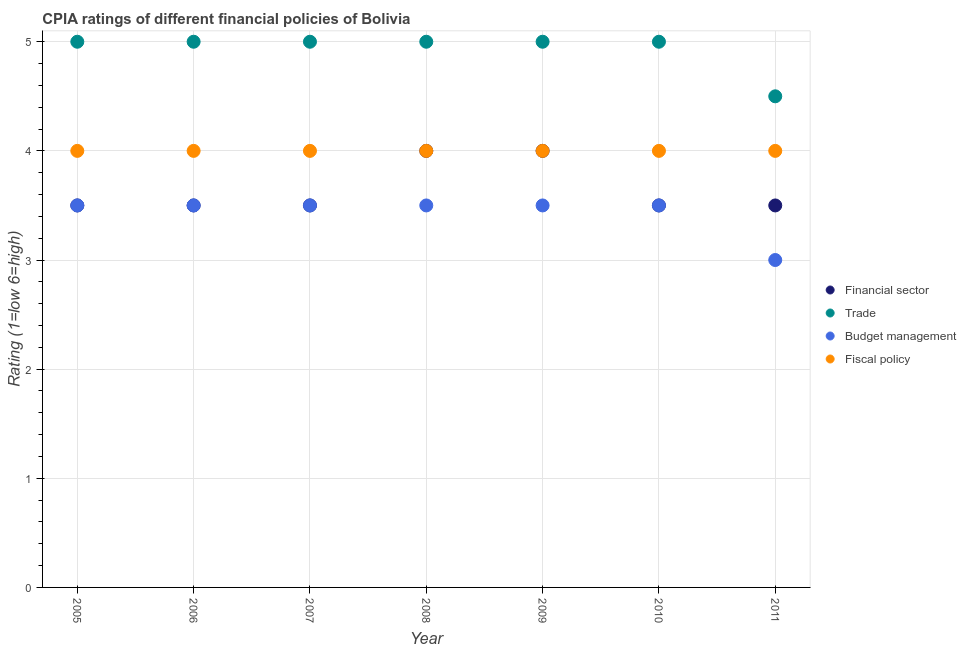Is the number of dotlines equal to the number of legend labels?
Offer a terse response. Yes. Across all years, what is the maximum cpia rating of financial sector?
Provide a short and direct response. 4. In which year was the cpia rating of financial sector maximum?
Provide a succinct answer. 2008. What is the difference between the cpia rating of trade in 2007 and that in 2008?
Keep it short and to the point. 0. What is the difference between the cpia rating of fiscal policy in 2005 and the cpia rating of budget management in 2009?
Ensure brevity in your answer.  0.5. In how many years, is the cpia rating of trade greater than 1.2?
Your response must be concise. 7. What is the ratio of the cpia rating of fiscal policy in 2006 to that in 2009?
Make the answer very short. 1. Is the cpia rating of financial sector in 2005 less than that in 2008?
Provide a succinct answer. Yes. In how many years, is the cpia rating of financial sector greater than the average cpia rating of financial sector taken over all years?
Provide a succinct answer. 2. Is the sum of the cpia rating of budget management in 2009 and 2010 greater than the maximum cpia rating of trade across all years?
Ensure brevity in your answer.  Yes. Is it the case that in every year, the sum of the cpia rating of fiscal policy and cpia rating of financial sector is greater than the sum of cpia rating of trade and cpia rating of budget management?
Ensure brevity in your answer.  Yes. Does the cpia rating of trade monotonically increase over the years?
Keep it short and to the point. No. Is the cpia rating of financial sector strictly greater than the cpia rating of trade over the years?
Ensure brevity in your answer.  No. Is the cpia rating of trade strictly less than the cpia rating of fiscal policy over the years?
Your answer should be compact. No. How many years are there in the graph?
Keep it short and to the point. 7. What is the difference between two consecutive major ticks on the Y-axis?
Your response must be concise. 1. Where does the legend appear in the graph?
Offer a very short reply. Center right. What is the title of the graph?
Provide a short and direct response. CPIA ratings of different financial policies of Bolivia. Does "Fish species" appear as one of the legend labels in the graph?
Provide a short and direct response. No. What is the label or title of the Y-axis?
Keep it short and to the point. Rating (1=low 6=high). What is the Rating (1=low 6=high) of Financial sector in 2005?
Provide a short and direct response. 3.5. What is the Rating (1=low 6=high) of Trade in 2005?
Your response must be concise. 5. What is the Rating (1=low 6=high) in Financial sector in 2006?
Keep it short and to the point. 3.5. What is the Rating (1=low 6=high) in Trade in 2006?
Offer a very short reply. 5. What is the Rating (1=low 6=high) in Budget management in 2006?
Make the answer very short. 3.5. What is the Rating (1=low 6=high) in Financial sector in 2008?
Your answer should be compact. 4. What is the Rating (1=low 6=high) in Financial sector in 2009?
Provide a short and direct response. 4. What is the Rating (1=low 6=high) in Fiscal policy in 2009?
Offer a very short reply. 4. What is the Rating (1=low 6=high) in Financial sector in 2010?
Provide a short and direct response. 3.5. What is the Rating (1=low 6=high) in Budget management in 2010?
Offer a terse response. 3.5. What is the Rating (1=low 6=high) of Financial sector in 2011?
Ensure brevity in your answer.  3.5. What is the Rating (1=low 6=high) of Trade in 2011?
Give a very brief answer. 4.5. What is the Rating (1=low 6=high) of Budget management in 2011?
Give a very brief answer. 3. Across all years, what is the maximum Rating (1=low 6=high) of Budget management?
Make the answer very short. 3.5. Across all years, what is the minimum Rating (1=low 6=high) of Budget management?
Your response must be concise. 3. Across all years, what is the minimum Rating (1=low 6=high) in Fiscal policy?
Offer a terse response. 4. What is the total Rating (1=low 6=high) of Financial sector in the graph?
Offer a terse response. 25.5. What is the total Rating (1=low 6=high) of Trade in the graph?
Your answer should be compact. 34.5. What is the difference between the Rating (1=low 6=high) in Financial sector in 2005 and that in 2006?
Make the answer very short. 0. What is the difference between the Rating (1=low 6=high) in Trade in 2005 and that in 2006?
Ensure brevity in your answer.  0. What is the difference between the Rating (1=low 6=high) of Fiscal policy in 2005 and that in 2006?
Provide a short and direct response. 0. What is the difference between the Rating (1=low 6=high) of Trade in 2005 and that in 2007?
Ensure brevity in your answer.  0. What is the difference between the Rating (1=low 6=high) in Budget management in 2005 and that in 2007?
Offer a terse response. 0. What is the difference between the Rating (1=low 6=high) in Budget management in 2005 and that in 2008?
Give a very brief answer. 0. What is the difference between the Rating (1=low 6=high) of Fiscal policy in 2005 and that in 2008?
Provide a succinct answer. 0. What is the difference between the Rating (1=low 6=high) in Trade in 2005 and that in 2010?
Keep it short and to the point. 0. What is the difference between the Rating (1=low 6=high) in Fiscal policy in 2005 and that in 2010?
Your answer should be very brief. 0. What is the difference between the Rating (1=low 6=high) in Financial sector in 2005 and that in 2011?
Make the answer very short. 0. What is the difference between the Rating (1=low 6=high) of Budget management in 2005 and that in 2011?
Provide a succinct answer. 0.5. What is the difference between the Rating (1=low 6=high) of Trade in 2006 and that in 2007?
Provide a short and direct response. 0. What is the difference between the Rating (1=low 6=high) of Fiscal policy in 2006 and that in 2007?
Keep it short and to the point. 0. What is the difference between the Rating (1=low 6=high) in Financial sector in 2006 and that in 2008?
Provide a succinct answer. -0.5. What is the difference between the Rating (1=low 6=high) of Budget management in 2006 and that in 2009?
Keep it short and to the point. 0. What is the difference between the Rating (1=low 6=high) in Fiscal policy in 2006 and that in 2009?
Offer a terse response. 0. What is the difference between the Rating (1=low 6=high) of Financial sector in 2006 and that in 2010?
Offer a very short reply. 0. What is the difference between the Rating (1=low 6=high) in Budget management in 2006 and that in 2010?
Your answer should be very brief. 0. What is the difference between the Rating (1=low 6=high) of Fiscal policy in 2006 and that in 2010?
Provide a succinct answer. 0. What is the difference between the Rating (1=low 6=high) of Financial sector in 2006 and that in 2011?
Make the answer very short. 0. What is the difference between the Rating (1=low 6=high) in Trade in 2006 and that in 2011?
Make the answer very short. 0.5. What is the difference between the Rating (1=low 6=high) of Budget management in 2007 and that in 2008?
Give a very brief answer. 0. What is the difference between the Rating (1=low 6=high) in Budget management in 2007 and that in 2009?
Ensure brevity in your answer.  0. What is the difference between the Rating (1=low 6=high) of Financial sector in 2007 and that in 2010?
Offer a terse response. 0. What is the difference between the Rating (1=low 6=high) of Budget management in 2007 and that in 2010?
Keep it short and to the point. 0. What is the difference between the Rating (1=low 6=high) of Budget management in 2007 and that in 2011?
Provide a short and direct response. 0.5. What is the difference between the Rating (1=low 6=high) of Financial sector in 2008 and that in 2009?
Your response must be concise. 0. What is the difference between the Rating (1=low 6=high) in Fiscal policy in 2008 and that in 2009?
Your answer should be very brief. 0. What is the difference between the Rating (1=low 6=high) in Financial sector in 2008 and that in 2010?
Your response must be concise. 0.5. What is the difference between the Rating (1=low 6=high) of Budget management in 2008 and that in 2011?
Make the answer very short. 0.5. What is the difference between the Rating (1=low 6=high) of Budget management in 2009 and that in 2010?
Give a very brief answer. 0. What is the difference between the Rating (1=low 6=high) in Budget management in 2009 and that in 2011?
Your answer should be compact. 0.5. What is the difference between the Rating (1=low 6=high) of Fiscal policy in 2009 and that in 2011?
Provide a short and direct response. 0. What is the difference between the Rating (1=low 6=high) of Financial sector in 2010 and that in 2011?
Keep it short and to the point. 0. What is the difference between the Rating (1=low 6=high) in Trade in 2005 and the Rating (1=low 6=high) in Budget management in 2006?
Offer a terse response. 1.5. What is the difference between the Rating (1=low 6=high) in Trade in 2005 and the Rating (1=low 6=high) in Fiscal policy in 2006?
Make the answer very short. 1. What is the difference between the Rating (1=low 6=high) of Financial sector in 2005 and the Rating (1=low 6=high) of Budget management in 2007?
Provide a short and direct response. 0. What is the difference between the Rating (1=low 6=high) of Financial sector in 2005 and the Rating (1=low 6=high) of Fiscal policy in 2007?
Your answer should be very brief. -0.5. What is the difference between the Rating (1=low 6=high) of Trade in 2005 and the Rating (1=low 6=high) of Budget management in 2007?
Make the answer very short. 1.5. What is the difference between the Rating (1=low 6=high) of Trade in 2005 and the Rating (1=low 6=high) of Fiscal policy in 2007?
Your answer should be very brief. 1. What is the difference between the Rating (1=low 6=high) in Financial sector in 2005 and the Rating (1=low 6=high) in Trade in 2008?
Offer a terse response. -1.5. What is the difference between the Rating (1=low 6=high) in Trade in 2005 and the Rating (1=low 6=high) in Budget management in 2008?
Your response must be concise. 1.5. What is the difference between the Rating (1=low 6=high) in Trade in 2005 and the Rating (1=low 6=high) in Fiscal policy in 2008?
Your response must be concise. 1. What is the difference between the Rating (1=low 6=high) of Financial sector in 2005 and the Rating (1=low 6=high) of Trade in 2009?
Provide a succinct answer. -1.5. What is the difference between the Rating (1=low 6=high) in Trade in 2005 and the Rating (1=low 6=high) in Fiscal policy in 2009?
Your answer should be compact. 1. What is the difference between the Rating (1=low 6=high) in Financial sector in 2005 and the Rating (1=low 6=high) in Fiscal policy in 2010?
Ensure brevity in your answer.  -0.5. What is the difference between the Rating (1=low 6=high) of Trade in 2005 and the Rating (1=low 6=high) of Fiscal policy in 2010?
Provide a succinct answer. 1. What is the difference between the Rating (1=low 6=high) of Budget management in 2005 and the Rating (1=low 6=high) of Fiscal policy in 2010?
Offer a very short reply. -0.5. What is the difference between the Rating (1=low 6=high) of Trade in 2005 and the Rating (1=low 6=high) of Budget management in 2011?
Your answer should be very brief. 2. What is the difference between the Rating (1=low 6=high) in Trade in 2005 and the Rating (1=low 6=high) in Fiscal policy in 2011?
Offer a terse response. 1. What is the difference between the Rating (1=low 6=high) of Budget management in 2005 and the Rating (1=low 6=high) of Fiscal policy in 2011?
Give a very brief answer. -0.5. What is the difference between the Rating (1=low 6=high) in Financial sector in 2006 and the Rating (1=low 6=high) in Trade in 2007?
Keep it short and to the point. -1.5. What is the difference between the Rating (1=low 6=high) of Financial sector in 2006 and the Rating (1=low 6=high) of Budget management in 2007?
Keep it short and to the point. 0. What is the difference between the Rating (1=low 6=high) of Financial sector in 2006 and the Rating (1=low 6=high) of Fiscal policy in 2007?
Make the answer very short. -0.5. What is the difference between the Rating (1=low 6=high) of Budget management in 2006 and the Rating (1=low 6=high) of Fiscal policy in 2007?
Make the answer very short. -0.5. What is the difference between the Rating (1=low 6=high) of Trade in 2006 and the Rating (1=low 6=high) of Budget management in 2008?
Offer a very short reply. 1.5. What is the difference between the Rating (1=low 6=high) in Budget management in 2006 and the Rating (1=low 6=high) in Fiscal policy in 2008?
Keep it short and to the point. -0.5. What is the difference between the Rating (1=low 6=high) of Financial sector in 2006 and the Rating (1=low 6=high) of Trade in 2009?
Your answer should be very brief. -1.5. What is the difference between the Rating (1=low 6=high) in Financial sector in 2006 and the Rating (1=low 6=high) in Budget management in 2009?
Keep it short and to the point. 0. What is the difference between the Rating (1=low 6=high) in Budget management in 2006 and the Rating (1=low 6=high) in Fiscal policy in 2009?
Make the answer very short. -0.5. What is the difference between the Rating (1=low 6=high) in Financial sector in 2006 and the Rating (1=low 6=high) in Trade in 2010?
Keep it short and to the point. -1.5. What is the difference between the Rating (1=low 6=high) of Trade in 2006 and the Rating (1=low 6=high) of Budget management in 2010?
Give a very brief answer. 1.5. What is the difference between the Rating (1=low 6=high) in Trade in 2006 and the Rating (1=low 6=high) in Fiscal policy in 2010?
Give a very brief answer. 1. What is the difference between the Rating (1=low 6=high) of Budget management in 2006 and the Rating (1=low 6=high) of Fiscal policy in 2010?
Make the answer very short. -0.5. What is the difference between the Rating (1=low 6=high) in Financial sector in 2006 and the Rating (1=low 6=high) in Trade in 2011?
Keep it short and to the point. -1. What is the difference between the Rating (1=low 6=high) of Financial sector in 2006 and the Rating (1=low 6=high) of Fiscal policy in 2011?
Give a very brief answer. -0.5. What is the difference between the Rating (1=low 6=high) of Trade in 2006 and the Rating (1=low 6=high) of Budget management in 2011?
Make the answer very short. 2. What is the difference between the Rating (1=low 6=high) in Budget management in 2006 and the Rating (1=low 6=high) in Fiscal policy in 2011?
Offer a terse response. -0.5. What is the difference between the Rating (1=low 6=high) of Financial sector in 2007 and the Rating (1=low 6=high) of Trade in 2008?
Your response must be concise. -1.5. What is the difference between the Rating (1=low 6=high) in Financial sector in 2007 and the Rating (1=low 6=high) in Fiscal policy in 2008?
Offer a very short reply. -0.5. What is the difference between the Rating (1=low 6=high) in Trade in 2007 and the Rating (1=low 6=high) in Budget management in 2008?
Provide a succinct answer. 1.5. What is the difference between the Rating (1=low 6=high) of Trade in 2007 and the Rating (1=low 6=high) of Fiscal policy in 2008?
Your answer should be very brief. 1. What is the difference between the Rating (1=low 6=high) in Financial sector in 2007 and the Rating (1=low 6=high) in Trade in 2009?
Provide a succinct answer. -1.5. What is the difference between the Rating (1=low 6=high) of Financial sector in 2007 and the Rating (1=low 6=high) of Budget management in 2009?
Offer a very short reply. 0. What is the difference between the Rating (1=low 6=high) of Financial sector in 2007 and the Rating (1=low 6=high) of Fiscal policy in 2009?
Provide a short and direct response. -0.5. What is the difference between the Rating (1=low 6=high) in Budget management in 2007 and the Rating (1=low 6=high) in Fiscal policy in 2009?
Your response must be concise. -0.5. What is the difference between the Rating (1=low 6=high) of Financial sector in 2007 and the Rating (1=low 6=high) of Trade in 2010?
Provide a short and direct response. -1.5. What is the difference between the Rating (1=low 6=high) of Financial sector in 2007 and the Rating (1=low 6=high) of Budget management in 2010?
Make the answer very short. 0. What is the difference between the Rating (1=low 6=high) of Trade in 2007 and the Rating (1=low 6=high) of Budget management in 2010?
Provide a short and direct response. 1.5. What is the difference between the Rating (1=low 6=high) in Trade in 2007 and the Rating (1=low 6=high) in Fiscal policy in 2010?
Your response must be concise. 1. What is the difference between the Rating (1=low 6=high) of Budget management in 2007 and the Rating (1=low 6=high) of Fiscal policy in 2010?
Provide a short and direct response. -0.5. What is the difference between the Rating (1=low 6=high) of Trade in 2007 and the Rating (1=low 6=high) of Budget management in 2011?
Ensure brevity in your answer.  2. What is the difference between the Rating (1=low 6=high) of Trade in 2007 and the Rating (1=low 6=high) of Fiscal policy in 2011?
Ensure brevity in your answer.  1. What is the difference between the Rating (1=low 6=high) in Budget management in 2007 and the Rating (1=low 6=high) in Fiscal policy in 2011?
Make the answer very short. -0.5. What is the difference between the Rating (1=low 6=high) in Financial sector in 2008 and the Rating (1=low 6=high) in Budget management in 2009?
Offer a very short reply. 0.5. What is the difference between the Rating (1=low 6=high) in Financial sector in 2008 and the Rating (1=low 6=high) in Fiscal policy in 2009?
Make the answer very short. 0. What is the difference between the Rating (1=low 6=high) of Budget management in 2008 and the Rating (1=low 6=high) of Fiscal policy in 2009?
Offer a very short reply. -0.5. What is the difference between the Rating (1=low 6=high) in Financial sector in 2008 and the Rating (1=low 6=high) in Budget management in 2010?
Ensure brevity in your answer.  0.5. What is the difference between the Rating (1=low 6=high) in Financial sector in 2008 and the Rating (1=low 6=high) in Fiscal policy in 2010?
Offer a terse response. 0. What is the difference between the Rating (1=low 6=high) of Trade in 2008 and the Rating (1=low 6=high) of Fiscal policy in 2010?
Make the answer very short. 1. What is the difference between the Rating (1=low 6=high) in Budget management in 2008 and the Rating (1=low 6=high) in Fiscal policy in 2010?
Ensure brevity in your answer.  -0.5. What is the difference between the Rating (1=low 6=high) of Financial sector in 2008 and the Rating (1=low 6=high) of Fiscal policy in 2011?
Your answer should be compact. 0. What is the difference between the Rating (1=low 6=high) of Trade in 2008 and the Rating (1=low 6=high) of Fiscal policy in 2011?
Offer a very short reply. 1. What is the difference between the Rating (1=low 6=high) of Financial sector in 2009 and the Rating (1=low 6=high) of Budget management in 2010?
Offer a terse response. 0.5. What is the difference between the Rating (1=low 6=high) in Financial sector in 2009 and the Rating (1=low 6=high) in Fiscal policy in 2010?
Provide a succinct answer. 0. What is the difference between the Rating (1=low 6=high) in Trade in 2009 and the Rating (1=low 6=high) in Budget management in 2010?
Offer a very short reply. 1.5. What is the difference between the Rating (1=low 6=high) in Financial sector in 2009 and the Rating (1=low 6=high) in Budget management in 2011?
Give a very brief answer. 1. What is the difference between the Rating (1=low 6=high) of Trade in 2009 and the Rating (1=low 6=high) of Budget management in 2011?
Give a very brief answer. 2. What is the difference between the Rating (1=low 6=high) in Trade in 2009 and the Rating (1=low 6=high) in Fiscal policy in 2011?
Your response must be concise. 1. What is the difference between the Rating (1=low 6=high) in Budget management in 2009 and the Rating (1=low 6=high) in Fiscal policy in 2011?
Ensure brevity in your answer.  -0.5. What is the difference between the Rating (1=low 6=high) in Financial sector in 2010 and the Rating (1=low 6=high) in Budget management in 2011?
Your answer should be very brief. 0.5. What is the average Rating (1=low 6=high) in Financial sector per year?
Give a very brief answer. 3.64. What is the average Rating (1=low 6=high) in Trade per year?
Make the answer very short. 4.93. What is the average Rating (1=low 6=high) in Budget management per year?
Keep it short and to the point. 3.43. What is the average Rating (1=low 6=high) of Fiscal policy per year?
Offer a terse response. 4. In the year 2005, what is the difference between the Rating (1=low 6=high) in Financial sector and Rating (1=low 6=high) in Trade?
Offer a very short reply. -1.5. In the year 2005, what is the difference between the Rating (1=low 6=high) in Financial sector and Rating (1=low 6=high) in Budget management?
Provide a short and direct response. 0. In the year 2005, what is the difference between the Rating (1=low 6=high) in Financial sector and Rating (1=low 6=high) in Fiscal policy?
Provide a succinct answer. -0.5. In the year 2005, what is the difference between the Rating (1=low 6=high) of Budget management and Rating (1=low 6=high) of Fiscal policy?
Your answer should be very brief. -0.5. In the year 2006, what is the difference between the Rating (1=low 6=high) of Financial sector and Rating (1=low 6=high) of Trade?
Provide a succinct answer. -1.5. In the year 2006, what is the difference between the Rating (1=low 6=high) in Trade and Rating (1=low 6=high) in Budget management?
Provide a succinct answer. 1.5. In the year 2006, what is the difference between the Rating (1=low 6=high) in Trade and Rating (1=low 6=high) in Fiscal policy?
Make the answer very short. 1. In the year 2007, what is the difference between the Rating (1=low 6=high) in Trade and Rating (1=low 6=high) in Budget management?
Your answer should be very brief. 1.5. In the year 2007, what is the difference between the Rating (1=low 6=high) in Trade and Rating (1=low 6=high) in Fiscal policy?
Offer a very short reply. 1. In the year 2008, what is the difference between the Rating (1=low 6=high) of Financial sector and Rating (1=low 6=high) of Budget management?
Ensure brevity in your answer.  0.5. In the year 2008, what is the difference between the Rating (1=low 6=high) of Trade and Rating (1=low 6=high) of Fiscal policy?
Ensure brevity in your answer.  1. In the year 2009, what is the difference between the Rating (1=low 6=high) of Trade and Rating (1=low 6=high) of Fiscal policy?
Your answer should be very brief. 1. In the year 2010, what is the difference between the Rating (1=low 6=high) in Financial sector and Rating (1=low 6=high) in Budget management?
Provide a short and direct response. 0. In the year 2010, what is the difference between the Rating (1=low 6=high) in Financial sector and Rating (1=low 6=high) in Fiscal policy?
Ensure brevity in your answer.  -0.5. In the year 2010, what is the difference between the Rating (1=low 6=high) in Budget management and Rating (1=low 6=high) in Fiscal policy?
Provide a succinct answer. -0.5. In the year 2011, what is the difference between the Rating (1=low 6=high) in Financial sector and Rating (1=low 6=high) in Budget management?
Your answer should be compact. 0.5. In the year 2011, what is the difference between the Rating (1=low 6=high) of Financial sector and Rating (1=low 6=high) of Fiscal policy?
Ensure brevity in your answer.  -0.5. In the year 2011, what is the difference between the Rating (1=low 6=high) in Trade and Rating (1=low 6=high) in Fiscal policy?
Ensure brevity in your answer.  0.5. In the year 2011, what is the difference between the Rating (1=low 6=high) in Budget management and Rating (1=low 6=high) in Fiscal policy?
Make the answer very short. -1. What is the ratio of the Rating (1=low 6=high) in Financial sector in 2005 to that in 2006?
Offer a terse response. 1. What is the ratio of the Rating (1=low 6=high) in Trade in 2005 to that in 2006?
Make the answer very short. 1. What is the ratio of the Rating (1=low 6=high) of Fiscal policy in 2005 to that in 2006?
Provide a succinct answer. 1. What is the ratio of the Rating (1=low 6=high) in Financial sector in 2005 to that in 2007?
Offer a very short reply. 1. What is the ratio of the Rating (1=low 6=high) of Trade in 2005 to that in 2007?
Make the answer very short. 1. What is the ratio of the Rating (1=low 6=high) in Fiscal policy in 2005 to that in 2007?
Your answer should be compact. 1. What is the ratio of the Rating (1=low 6=high) in Financial sector in 2005 to that in 2008?
Provide a short and direct response. 0.88. What is the ratio of the Rating (1=low 6=high) of Budget management in 2005 to that in 2009?
Provide a short and direct response. 1. What is the ratio of the Rating (1=low 6=high) of Fiscal policy in 2005 to that in 2009?
Offer a very short reply. 1. What is the ratio of the Rating (1=low 6=high) of Financial sector in 2005 to that in 2010?
Provide a succinct answer. 1. What is the ratio of the Rating (1=low 6=high) of Trade in 2005 to that in 2010?
Make the answer very short. 1. What is the ratio of the Rating (1=low 6=high) of Budget management in 2005 to that in 2010?
Provide a short and direct response. 1. What is the ratio of the Rating (1=low 6=high) in Fiscal policy in 2005 to that in 2010?
Your response must be concise. 1. What is the ratio of the Rating (1=low 6=high) in Financial sector in 2006 to that in 2007?
Your response must be concise. 1. What is the ratio of the Rating (1=low 6=high) in Trade in 2006 to that in 2007?
Offer a terse response. 1. What is the ratio of the Rating (1=low 6=high) of Budget management in 2006 to that in 2007?
Your answer should be very brief. 1. What is the ratio of the Rating (1=low 6=high) in Financial sector in 2006 to that in 2008?
Offer a very short reply. 0.88. What is the ratio of the Rating (1=low 6=high) in Financial sector in 2006 to that in 2009?
Offer a terse response. 0.88. What is the ratio of the Rating (1=low 6=high) in Trade in 2006 to that in 2009?
Your answer should be very brief. 1. What is the ratio of the Rating (1=low 6=high) of Budget management in 2006 to that in 2009?
Your answer should be very brief. 1. What is the ratio of the Rating (1=low 6=high) of Trade in 2006 to that in 2010?
Your answer should be very brief. 1. What is the ratio of the Rating (1=low 6=high) of Budget management in 2006 to that in 2010?
Make the answer very short. 1. What is the ratio of the Rating (1=low 6=high) of Financial sector in 2006 to that in 2011?
Make the answer very short. 1. What is the ratio of the Rating (1=low 6=high) in Fiscal policy in 2006 to that in 2011?
Your response must be concise. 1. What is the ratio of the Rating (1=low 6=high) in Financial sector in 2007 to that in 2008?
Keep it short and to the point. 0.88. What is the ratio of the Rating (1=low 6=high) of Fiscal policy in 2007 to that in 2008?
Offer a terse response. 1. What is the ratio of the Rating (1=low 6=high) in Financial sector in 2007 to that in 2009?
Ensure brevity in your answer.  0.88. What is the ratio of the Rating (1=low 6=high) in Financial sector in 2007 to that in 2010?
Your answer should be very brief. 1. What is the ratio of the Rating (1=low 6=high) of Trade in 2007 to that in 2010?
Offer a terse response. 1. What is the ratio of the Rating (1=low 6=high) in Budget management in 2007 to that in 2010?
Keep it short and to the point. 1. What is the ratio of the Rating (1=low 6=high) of Fiscal policy in 2007 to that in 2010?
Provide a short and direct response. 1. What is the ratio of the Rating (1=low 6=high) of Financial sector in 2007 to that in 2011?
Provide a succinct answer. 1. What is the ratio of the Rating (1=low 6=high) of Budget management in 2007 to that in 2011?
Offer a very short reply. 1.17. What is the ratio of the Rating (1=low 6=high) of Fiscal policy in 2007 to that in 2011?
Provide a succinct answer. 1. What is the ratio of the Rating (1=low 6=high) of Financial sector in 2008 to that in 2009?
Your answer should be very brief. 1. What is the ratio of the Rating (1=low 6=high) of Trade in 2008 to that in 2010?
Provide a succinct answer. 1. What is the ratio of the Rating (1=low 6=high) of Budget management in 2008 to that in 2010?
Make the answer very short. 1. What is the ratio of the Rating (1=low 6=high) in Budget management in 2008 to that in 2011?
Provide a succinct answer. 1.17. What is the ratio of the Rating (1=low 6=high) in Fiscal policy in 2008 to that in 2011?
Ensure brevity in your answer.  1. What is the ratio of the Rating (1=low 6=high) of Budget management in 2009 to that in 2010?
Provide a succinct answer. 1. What is the ratio of the Rating (1=low 6=high) in Budget management in 2009 to that in 2011?
Give a very brief answer. 1.17. What is the ratio of the Rating (1=low 6=high) in Financial sector in 2010 to that in 2011?
Offer a terse response. 1. What is the ratio of the Rating (1=low 6=high) in Fiscal policy in 2010 to that in 2011?
Provide a succinct answer. 1. What is the difference between the highest and the second highest Rating (1=low 6=high) in Trade?
Make the answer very short. 0. What is the difference between the highest and the second highest Rating (1=low 6=high) of Budget management?
Make the answer very short. 0. What is the difference between the highest and the second highest Rating (1=low 6=high) in Fiscal policy?
Offer a very short reply. 0. What is the difference between the highest and the lowest Rating (1=low 6=high) in Financial sector?
Provide a short and direct response. 0.5. What is the difference between the highest and the lowest Rating (1=low 6=high) in Trade?
Your response must be concise. 0.5. What is the difference between the highest and the lowest Rating (1=low 6=high) of Fiscal policy?
Your answer should be compact. 0. 